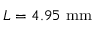<formula> <loc_0><loc_0><loc_500><loc_500>L = 4 . 9 5 m m</formula> 